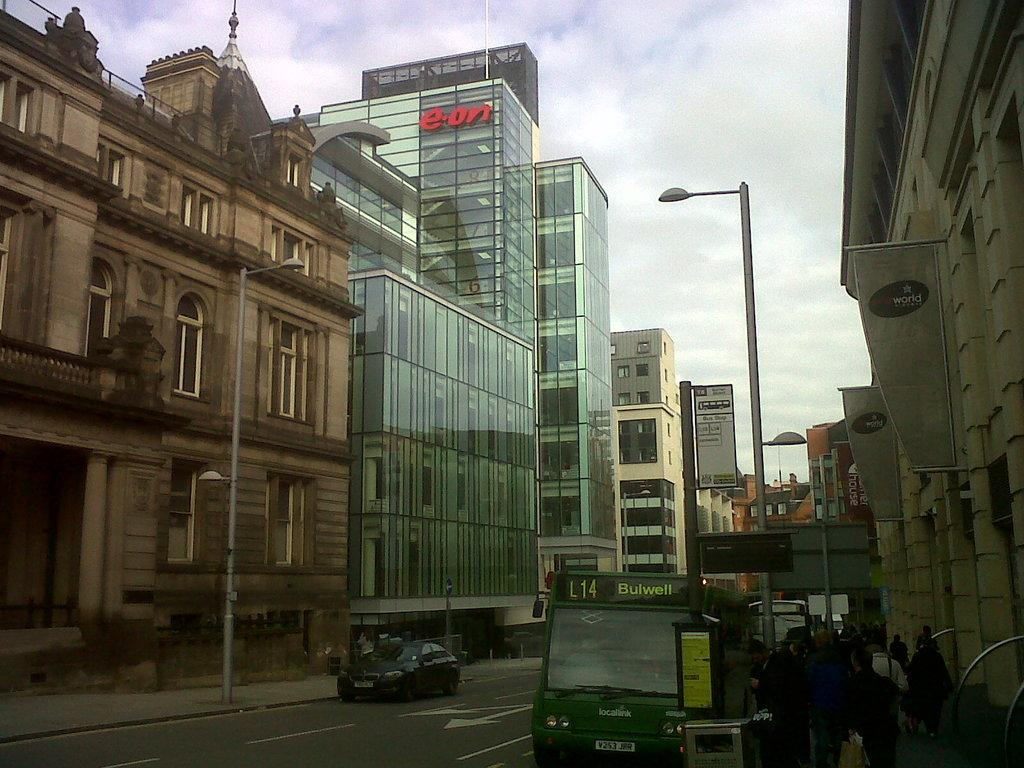What type of structures can be seen in the image? There are buildings in the image. What are the vertical objects on the sides of the road? Street poles are present in the image. What are the illuminated objects on the street poles? Street lights are visible in the image. What types of vehicles are on the road in the image? Motor vehicles are on the road in the image. What are the people doing on the road in the image? There are persons walking on the road in the image. What type of signs can be seen in the image? Advertisements are present in the image. What type of artistic objects can be seen in the image? Sculptures are visible in the image. What is visible in the sky in the image? The sky is visible in the image. What type of weather can be inferred from the sky in the image? Clouds are present in the sky, suggesting a partly cloudy day. What is the grandfather doing in the image? There is no mention of a grandfather in the image, so we cannot answer this question. What is the temperature in the image? The image does not provide information about the temperature, so we cannot answer this question. 